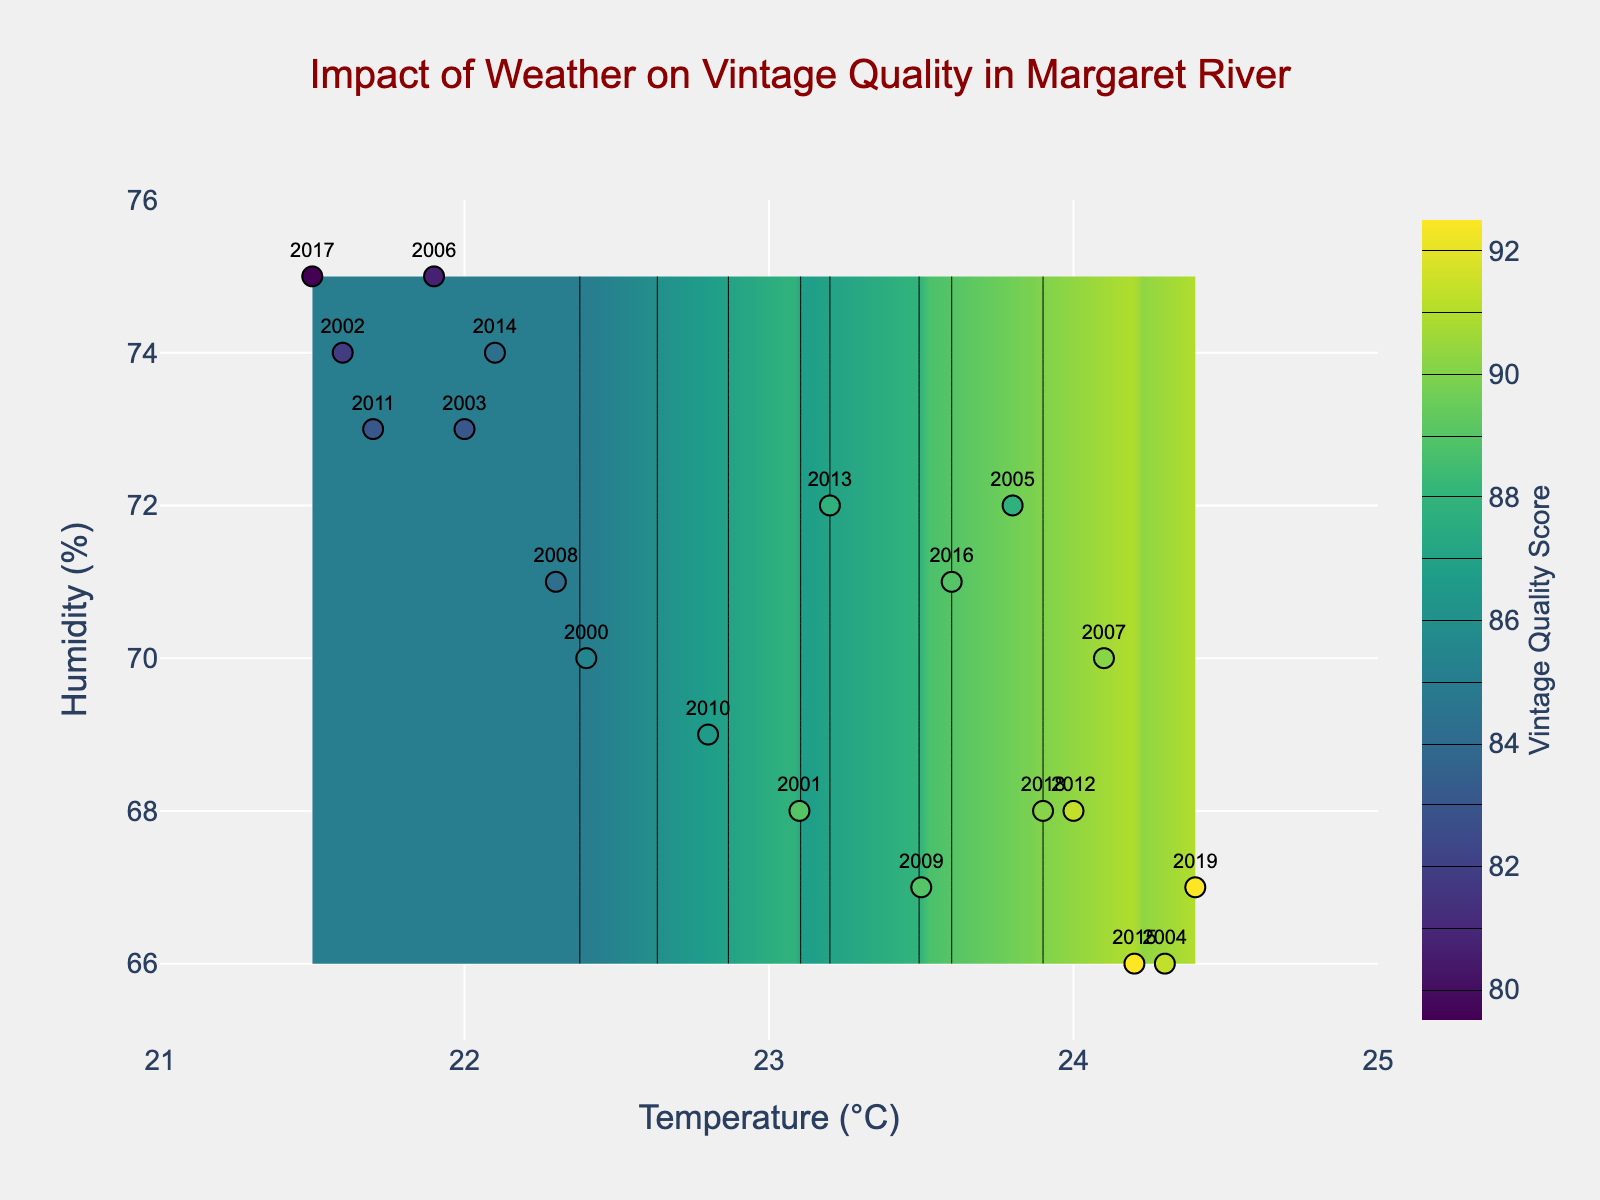What is the title of the figure? The title is located at the top of the figure and is clearly labeled.
Answer: Impact of Weather on Vintage Quality in Margaret River How many data points are represented in the scatter plot? Each data point represents a year, and by counting the markers, we determine the quantity.
Answer: 20 What is the range of the x-axis (Temperature (°C))? The x-axis ranges are provided at the bottom of the plot.
Answer: 21 to 25 Which year had the highest Vintage Quality Score, and what were its temperature and humidity? Identify the data point with the highest score on the color gradient; the corresponding year, temperature, and humidity are labeled nearby.
Answer: 2019; 24.4°C; 67% How does the Vintage Quality Score vary with temperature? Observe the color changes on the contour plot as the temperature changes to determine trends.
Answer: Higher temperatures generally correspond to higher Vintage Quality Scores What is the approximate Vintage Quality Score for a temperature of 22.5°C and humidity of 70%? Locate the point at (22.5°C, 70%) on the contour plot and observe the color or the contour lines around it for the score.
Answer: Approximately 85 Between which years does the temperature fluctuate the most? Compare the temperature values for all years and identify the maximum fluctuation by calculating the difference between the highest and lowest temperatures.
Answer: 2000 and 2019 Which year with a humidity of 75% has the lowest Vintage Quality Score? Focus on the data points with 75% humidity and compare their Vintage Quality Scores.
Answer: 2017 Based on the figure, what trend can be observed about the relationship between humidity and Vintage Quality Score? Analyze the contour plot's color gradation as humidity changes, with a focus on how scores vary.
Answer: Lower humidity tends to correspond to higher Vintage Quality Scores Which year's vintage quality would you expect to be more affected by an increase in temperature? Consider the years with moderate scores near higher-temperature regions on the contour plot, which may be more affected by temperature changes.
Answer: 2001 